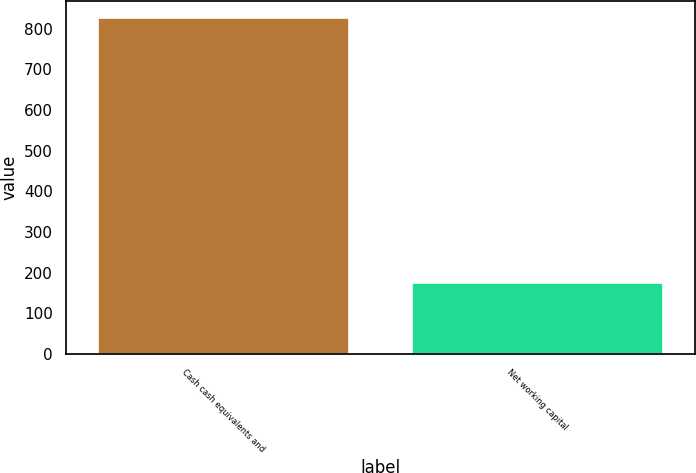Convert chart to OTSL. <chart><loc_0><loc_0><loc_500><loc_500><bar_chart><fcel>Cash cash equivalents and<fcel>Net working capital<nl><fcel>827.1<fcel>174<nl></chart> 